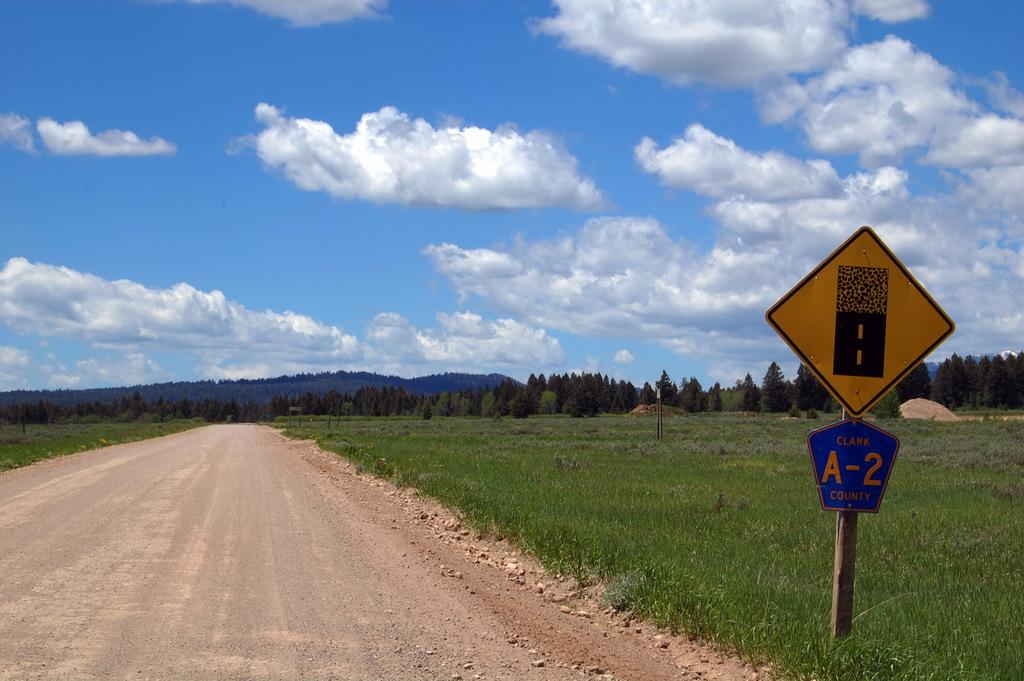<image>
Offer a succinct explanation of the picture presented. Gravel to paved road signs mark this A-2 county road. 